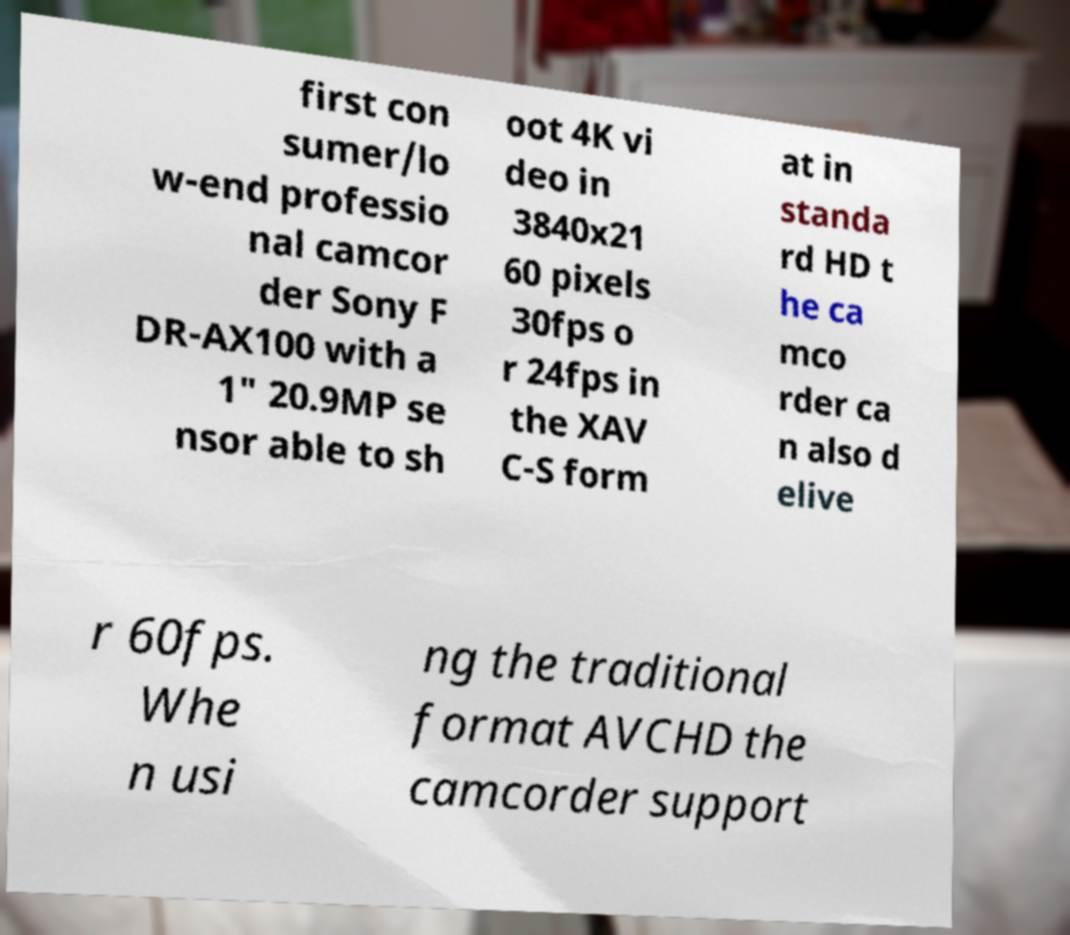Could you extract and type out the text from this image? first con sumer/lo w-end professio nal camcor der Sony F DR-AX100 with a 1" 20.9MP se nsor able to sh oot 4K vi deo in 3840x21 60 pixels 30fps o r 24fps in the XAV C-S form at in standa rd HD t he ca mco rder ca n also d elive r 60fps. Whe n usi ng the traditional format AVCHD the camcorder support 